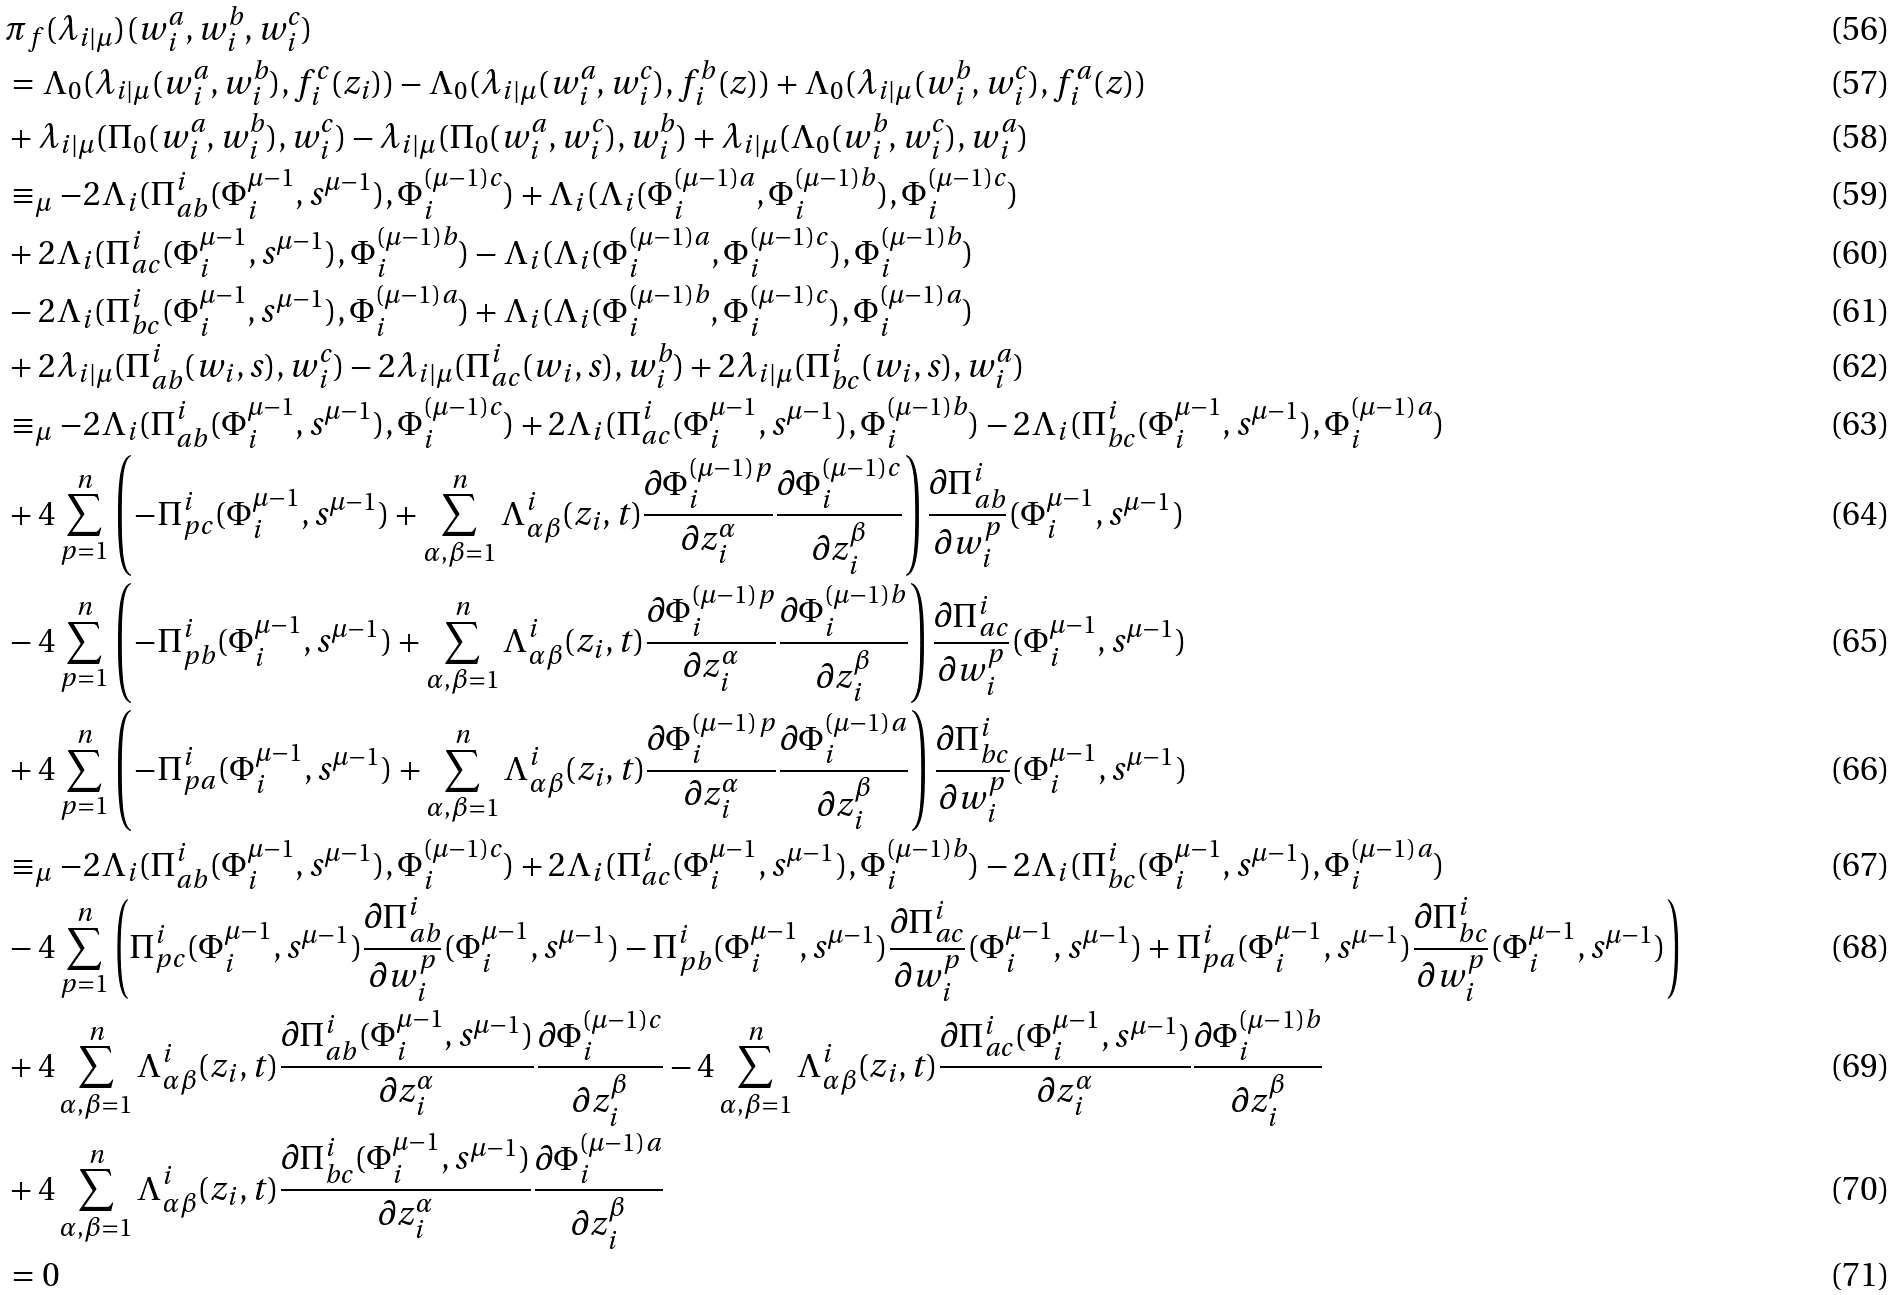<formula> <loc_0><loc_0><loc_500><loc_500>& \pi _ { f } ( \lambda _ { i | \mu } ) ( w _ { i } ^ { a } , w _ { i } ^ { b } , w _ { i } ^ { c } ) \\ & = \Lambda _ { 0 } ( \lambda _ { i | \mu } ( w _ { i } ^ { a } , w _ { i } ^ { b } ) , f _ { i } ^ { c } ( z _ { i } ) ) - \Lambda _ { 0 } ( \lambda _ { i | \mu } ( w _ { i } ^ { a } , w _ { i } ^ { c } ) , f _ { i } ^ { b } ( z ) ) + \Lambda _ { 0 } ( \lambda _ { i | \mu } ( w _ { i } ^ { b } , w _ { i } ^ { c } ) , f _ { i } ^ { a } ( z ) ) \\ & + \lambda _ { i | \mu } ( \Pi _ { 0 } ( w _ { i } ^ { a } , w _ { i } ^ { b } ) , w _ { i } ^ { c } ) - \lambda _ { i | \mu } ( \Pi _ { 0 } ( w _ { i } ^ { a } , w _ { i } ^ { c } ) , w _ { i } ^ { b } ) + \lambda _ { i | \mu } ( \Lambda _ { 0 } ( w _ { i } ^ { b } , w _ { i } ^ { c } ) , w _ { i } ^ { a } ) \\ & \equiv _ { \mu } - 2 \Lambda _ { i } ( \Pi _ { a b } ^ { i } ( \Phi _ { i } ^ { \mu - 1 } , s ^ { \mu - 1 } ) , \Phi _ { i } ^ { ( \mu - 1 ) c } ) + \Lambda _ { i } ( \Lambda _ { i } ( \Phi _ { i } ^ { ( \mu - 1 ) a } , \Phi _ { i } ^ { ( \mu - 1 ) b } ) , \Phi _ { i } ^ { ( \mu - 1 ) c } ) \\ & + 2 \Lambda _ { i } ( \Pi _ { a c } ^ { i } ( \Phi _ { i } ^ { \mu - 1 } , s ^ { \mu - 1 } ) , \Phi _ { i } ^ { ( \mu - 1 ) b } ) - \Lambda _ { i } ( \Lambda _ { i } ( \Phi _ { i } ^ { ( \mu - 1 ) a } , \Phi _ { i } ^ { ( \mu - 1 ) c } ) , \Phi _ { i } ^ { ( \mu - 1 ) b } ) \\ & - 2 \Lambda _ { i } ( \Pi _ { b c } ^ { i } ( \Phi _ { i } ^ { \mu - 1 } , s ^ { \mu - 1 } ) , \Phi _ { i } ^ { ( \mu - 1 ) a } ) + \Lambda _ { i } ( \Lambda _ { i } ( \Phi _ { i } ^ { ( \mu - 1 ) b } , \Phi _ { i } ^ { ( \mu - 1 ) c } ) , \Phi _ { i } ^ { ( \mu - 1 ) a } ) \\ & + 2 \lambda _ { i | \mu } ( \Pi _ { a b } ^ { i } ( w _ { i } , s ) , w _ { i } ^ { c } ) - 2 \lambda _ { i | \mu } ( \Pi _ { a c } ^ { i } ( w _ { i } , s ) , w _ { i } ^ { b } ) + 2 \lambda _ { i | \mu } ( \Pi _ { b c } ^ { i } ( w _ { i } , s ) , w _ { i } ^ { a } ) \\ & \equiv _ { \mu } - 2 \Lambda _ { i } ( \Pi _ { a b } ^ { i } ( \Phi _ { i } ^ { \mu - 1 } , s ^ { \mu - 1 } ) , \Phi _ { i } ^ { ( \mu - 1 ) c } ) + 2 \Lambda _ { i } ( \Pi _ { a c } ^ { i } ( \Phi _ { i } ^ { \mu - 1 } , s ^ { \mu - 1 } ) , \Phi _ { i } ^ { ( \mu - 1 ) b } ) - 2 \Lambda _ { i } ( \Pi _ { b c } ^ { i } ( \Phi _ { i } ^ { \mu - 1 } , s ^ { \mu - 1 } ) , \Phi _ { i } ^ { ( \mu - 1 ) a } ) \\ & + 4 \sum _ { p = 1 } ^ { n } \left ( - \Pi _ { p c } ^ { i } ( \Phi _ { i } ^ { \mu - 1 } , s ^ { \mu - 1 } ) + \sum _ { \alpha , \beta = 1 } ^ { n } \Lambda _ { \alpha \beta } ^ { i } ( z _ { i } , t ) \frac { \partial \Phi _ { i } ^ { ( \mu - 1 ) p } } { \partial z _ { i } ^ { \alpha } } \frac { \partial \Phi _ { i } ^ { ( \mu - 1 ) c } } { \partial z _ { i } ^ { \beta } } \right ) \frac { \partial \Pi _ { a b } ^ { i } } { \partial w _ { i } ^ { p } } ( \Phi _ { i } ^ { \mu - 1 } , s ^ { \mu - 1 } ) \\ & - 4 \sum _ { p = 1 } ^ { n } \left ( - \Pi _ { p b } ^ { i } ( \Phi _ { i } ^ { \mu - 1 } , s ^ { \mu - 1 } ) + \sum _ { \alpha , \beta = 1 } ^ { n } \Lambda _ { \alpha \beta } ^ { i } ( z _ { i } , t ) \frac { \partial \Phi _ { i } ^ { ( \mu - 1 ) p } } { \partial z _ { i } ^ { \alpha } } \frac { \partial \Phi _ { i } ^ { ( \mu - 1 ) b } } { \partial z _ { i } ^ { \beta } } \right ) \frac { \partial \Pi _ { a c } ^ { i } } { \partial w _ { i } ^ { p } } ( \Phi _ { i } ^ { \mu - 1 } , s ^ { \mu - 1 } ) \\ & + 4 \sum _ { p = 1 } ^ { n } \left ( - \Pi _ { p a } ^ { i } ( \Phi _ { i } ^ { \mu - 1 } , s ^ { \mu - 1 } ) + \sum _ { \alpha , \beta = 1 } ^ { n } \Lambda _ { \alpha \beta } ^ { i } ( z _ { i } , t ) \frac { \partial \Phi _ { i } ^ { ( \mu - 1 ) p } } { \partial z _ { i } ^ { \alpha } } \frac { \partial \Phi _ { i } ^ { ( \mu - 1 ) a } } { \partial z _ { i } ^ { \beta } } \right ) \frac { \partial \Pi _ { b c } ^ { i } } { \partial w _ { i } ^ { p } } ( \Phi _ { i } ^ { \mu - 1 } , s ^ { \mu - 1 } ) \\ & \equiv _ { \mu } - 2 \Lambda _ { i } ( \Pi _ { a b } ^ { i } ( \Phi _ { i } ^ { \mu - 1 } , s ^ { \mu - 1 } ) , \Phi _ { i } ^ { ( \mu - 1 ) c } ) + 2 \Lambda _ { i } ( \Pi _ { a c } ^ { i } ( \Phi _ { i } ^ { \mu - 1 } , s ^ { \mu - 1 } ) , \Phi _ { i } ^ { ( \mu - 1 ) b } ) - 2 \Lambda _ { i } ( \Pi _ { b c } ^ { i } ( \Phi _ { i } ^ { \mu - 1 } , s ^ { \mu - 1 } ) , \Phi _ { i } ^ { ( \mu - 1 ) a } ) \\ & - 4 \sum _ { p = 1 } ^ { n } \left ( \Pi _ { p c } ^ { i } ( \Phi _ { i } ^ { \mu - 1 } , s ^ { \mu - 1 } ) \frac { \partial \Pi _ { a b } ^ { i } } { \partial w _ { i } ^ { p } } ( \Phi _ { i } ^ { \mu - 1 } , s ^ { \mu - 1 } ) - \Pi _ { p b } ^ { i } ( \Phi _ { i } ^ { \mu - 1 } , s ^ { \mu - 1 } ) \frac { \partial \Pi _ { a c } ^ { i } } { \partial w _ { i } ^ { p } } ( \Phi _ { i } ^ { \mu - 1 } , s ^ { \mu - 1 } ) + \Pi _ { p a } ^ { i } ( \Phi _ { i } ^ { \mu - 1 } , s ^ { \mu - 1 } ) \frac { \partial \Pi _ { b c } ^ { i } } { \partial w _ { i } ^ { p } } ( \Phi _ { i } ^ { \mu - 1 } , s ^ { \mu - 1 } ) \right ) \\ & + 4 \sum _ { \alpha , \beta = 1 } ^ { n } \Lambda _ { \alpha \beta } ^ { i } ( z _ { i } , t ) \frac { \partial \Pi _ { a b } ^ { i } ( \Phi _ { i } ^ { \mu - 1 } , s ^ { \mu - 1 } ) } { \partial z _ { i } ^ { \alpha } } \frac { \partial \Phi _ { i } ^ { ( \mu - 1 ) c } } { \partial z _ { i } ^ { \beta } } - 4 \sum _ { \alpha , \beta = 1 } ^ { n } \Lambda _ { \alpha \beta } ^ { i } ( z _ { i } , t ) \frac { \partial \Pi _ { a c } ^ { i } ( \Phi _ { i } ^ { \mu - 1 } , s ^ { \mu - 1 } ) } { \partial z _ { i } ^ { \alpha } } \frac { \partial \Phi _ { i } ^ { ( \mu - 1 ) b } } { \partial z _ { i } ^ { \beta } } \\ & + 4 \sum _ { \alpha , \beta = 1 } ^ { n } \Lambda _ { \alpha \beta } ^ { i } ( z _ { i } , t ) \frac { \partial \Pi _ { b c } ^ { i } ( \Phi _ { i } ^ { \mu - 1 } , s ^ { \mu - 1 } ) } { \partial z _ { i } ^ { \alpha } } \frac { \partial \Phi _ { i } ^ { ( \mu - 1 ) a } } { \partial z _ { i } ^ { \beta } } \\ & = 0</formula> 